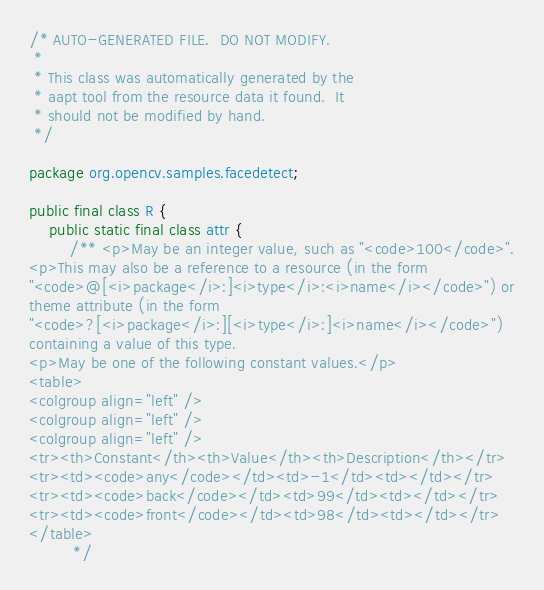Convert code to text. <code><loc_0><loc_0><loc_500><loc_500><_Java_>/* AUTO-GENERATED FILE.  DO NOT MODIFY.
 *
 * This class was automatically generated by the
 * aapt tool from the resource data it found.  It
 * should not be modified by hand.
 */

package org.opencv.samples.facedetect;

public final class R {
    public static final class attr {
        /** <p>May be an integer value, such as "<code>100</code>".
<p>This may also be a reference to a resource (in the form
"<code>@[<i>package</i>:]<i>type</i>:<i>name</i></code>") or
theme attribute (in the form
"<code>?[<i>package</i>:][<i>type</i>:]<i>name</i></code>")
containing a value of this type.
<p>May be one of the following constant values.</p>
<table>
<colgroup align="left" />
<colgroup align="left" />
<colgroup align="left" />
<tr><th>Constant</th><th>Value</th><th>Description</th></tr>
<tr><td><code>any</code></td><td>-1</td><td></td></tr>
<tr><td><code>back</code></td><td>99</td><td></td></tr>
<tr><td><code>front</code></td><td>98</td><td></td></tr>
</table>
         */</code> 